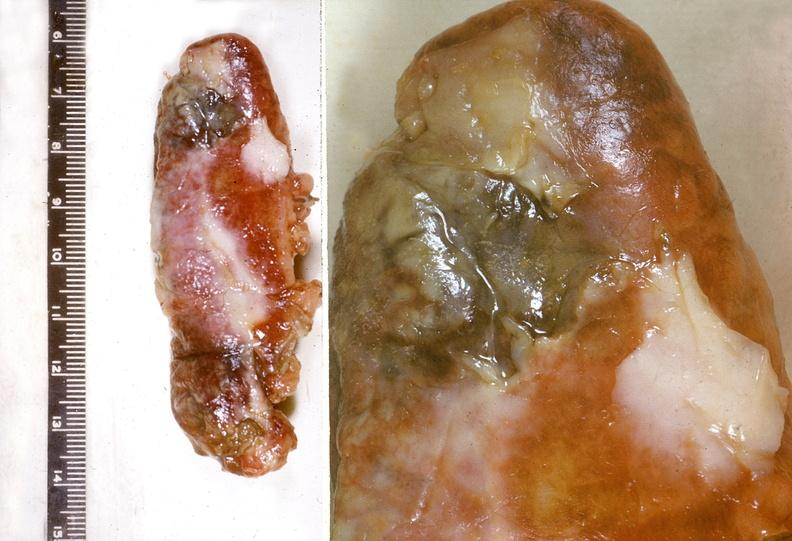what is present?
Answer the question using a single word or phrase. Gastrointestinal 